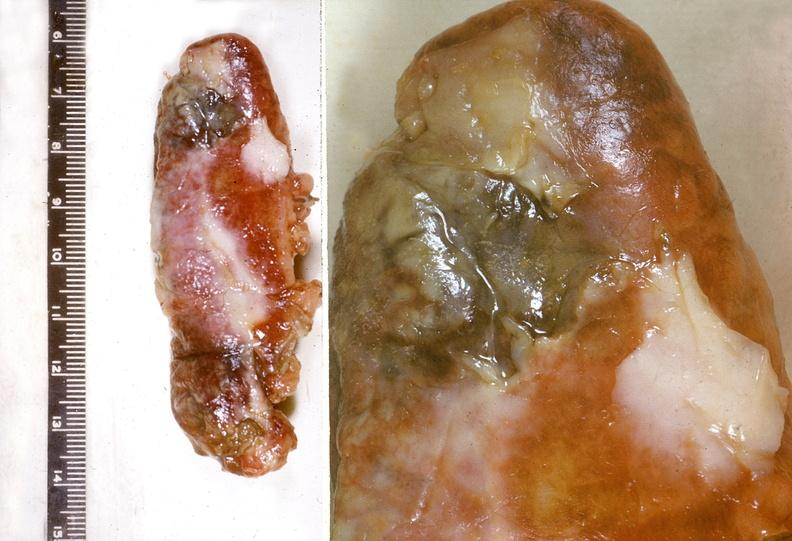what is present?
Answer the question using a single word or phrase. Gastrointestinal 